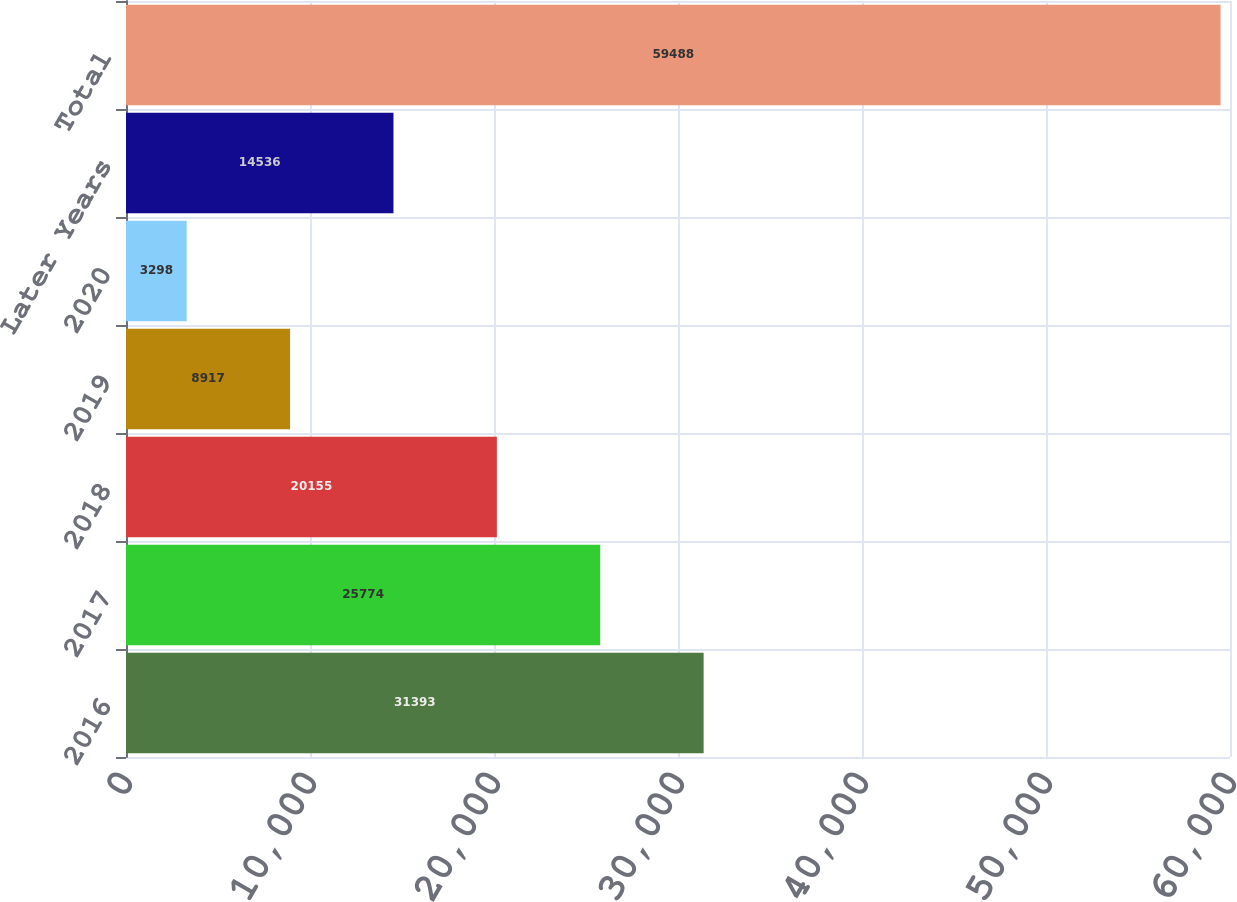Convert chart to OTSL. <chart><loc_0><loc_0><loc_500><loc_500><bar_chart><fcel>2016<fcel>2017<fcel>2018<fcel>2019<fcel>2020<fcel>Later Years<fcel>Total<nl><fcel>31393<fcel>25774<fcel>20155<fcel>8917<fcel>3298<fcel>14536<fcel>59488<nl></chart> 